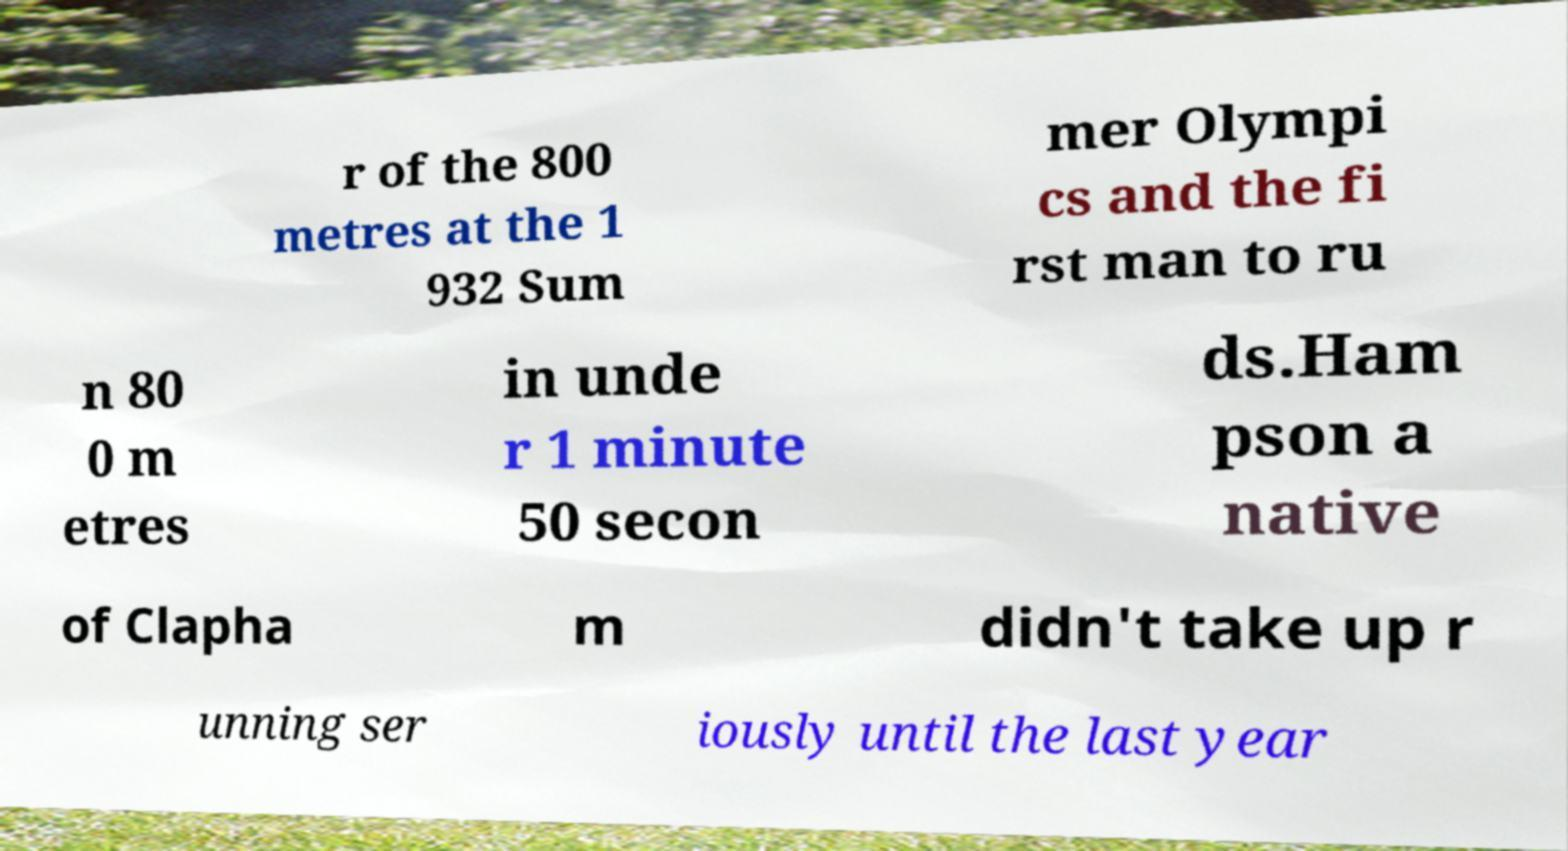Could you assist in decoding the text presented in this image and type it out clearly? r of the 800 metres at the 1 932 Sum mer Olympi cs and the fi rst man to ru n 80 0 m etres in unde r 1 minute 50 secon ds.Ham pson a native of Clapha m didn't take up r unning ser iously until the last year 